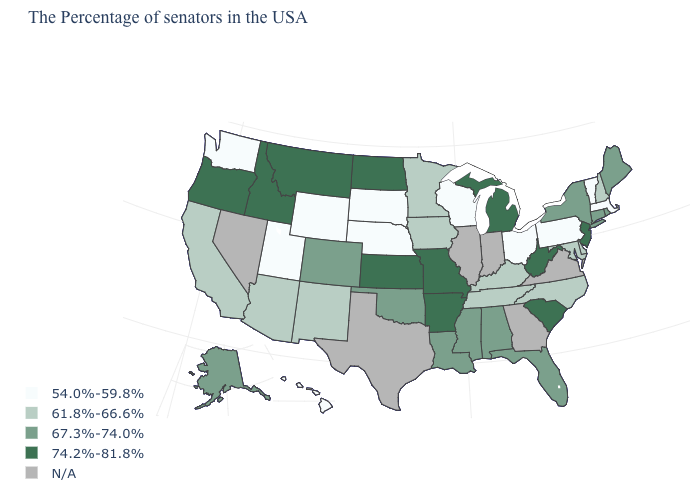Which states have the lowest value in the USA?
Write a very short answer. Massachusetts, Vermont, Pennsylvania, Ohio, Wisconsin, Nebraska, South Dakota, Wyoming, Utah, Washington, Hawaii. What is the value of Massachusetts?
Give a very brief answer. 54.0%-59.8%. What is the value of Virginia?
Short answer required. N/A. Name the states that have a value in the range 54.0%-59.8%?
Write a very short answer. Massachusetts, Vermont, Pennsylvania, Ohio, Wisconsin, Nebraska, South Dakota, Wyoming, Utah, Washington, Hawaii. What is the highest value in the USA?
Give a very brief answer. 74.2%-81.8%. Name the states that have a value in the range 54.0%-59.8%?
Give a very brief answer. Massachusetts, Vermont, Pennsylvania, Ohio, Wisconsin, Nebraska, South Dakota, Wyoming, Utah, Washington, Hawaii. Name the states that have a value in the range N/A?
Give a very brief answer. Virginia, Georgia, Indiana, Illinois, Texas, Nevada. Does Oklahoma have the lowest value in the USA?
Write a very short answer. No. Which states hav the highest value in the West?
Quick response, please. Montana, Idaho, Oregon. Does Pennsylvania have the highest value in the USA?
Write a very short answer. No. Among the states that border Michigan , which have the highest value?
Give a very brief answer. Ohio, Wisconsin. What is the highest value in the MidWest ?
Give a very brief answer. 74.2%-81.8%. Which states hav the highest value in the South?
Write a very short answer. South Carolina, West Virginia, Arkansas. Name the states that have a value in the range 67.3%-74.0%?
Short answer required. Maine, Rhode Island, Connecticut, New York, Florida, Alabama, Mississippi, Louisiana, Oklahoma, Colorado, Alaska. 